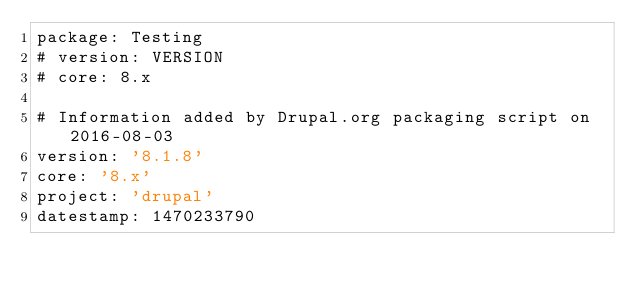<code> <loc_0><loc_0><loc_500><loc_500><_YAML_>package: Testing
# version: VERSION
# core: 8.x

# Information added by Drupal.org packaging script on 2016-08-03
version: '8.1.8'
core: '8.x'
project: 'drupal'
datestamp: 1470233790
</code> 